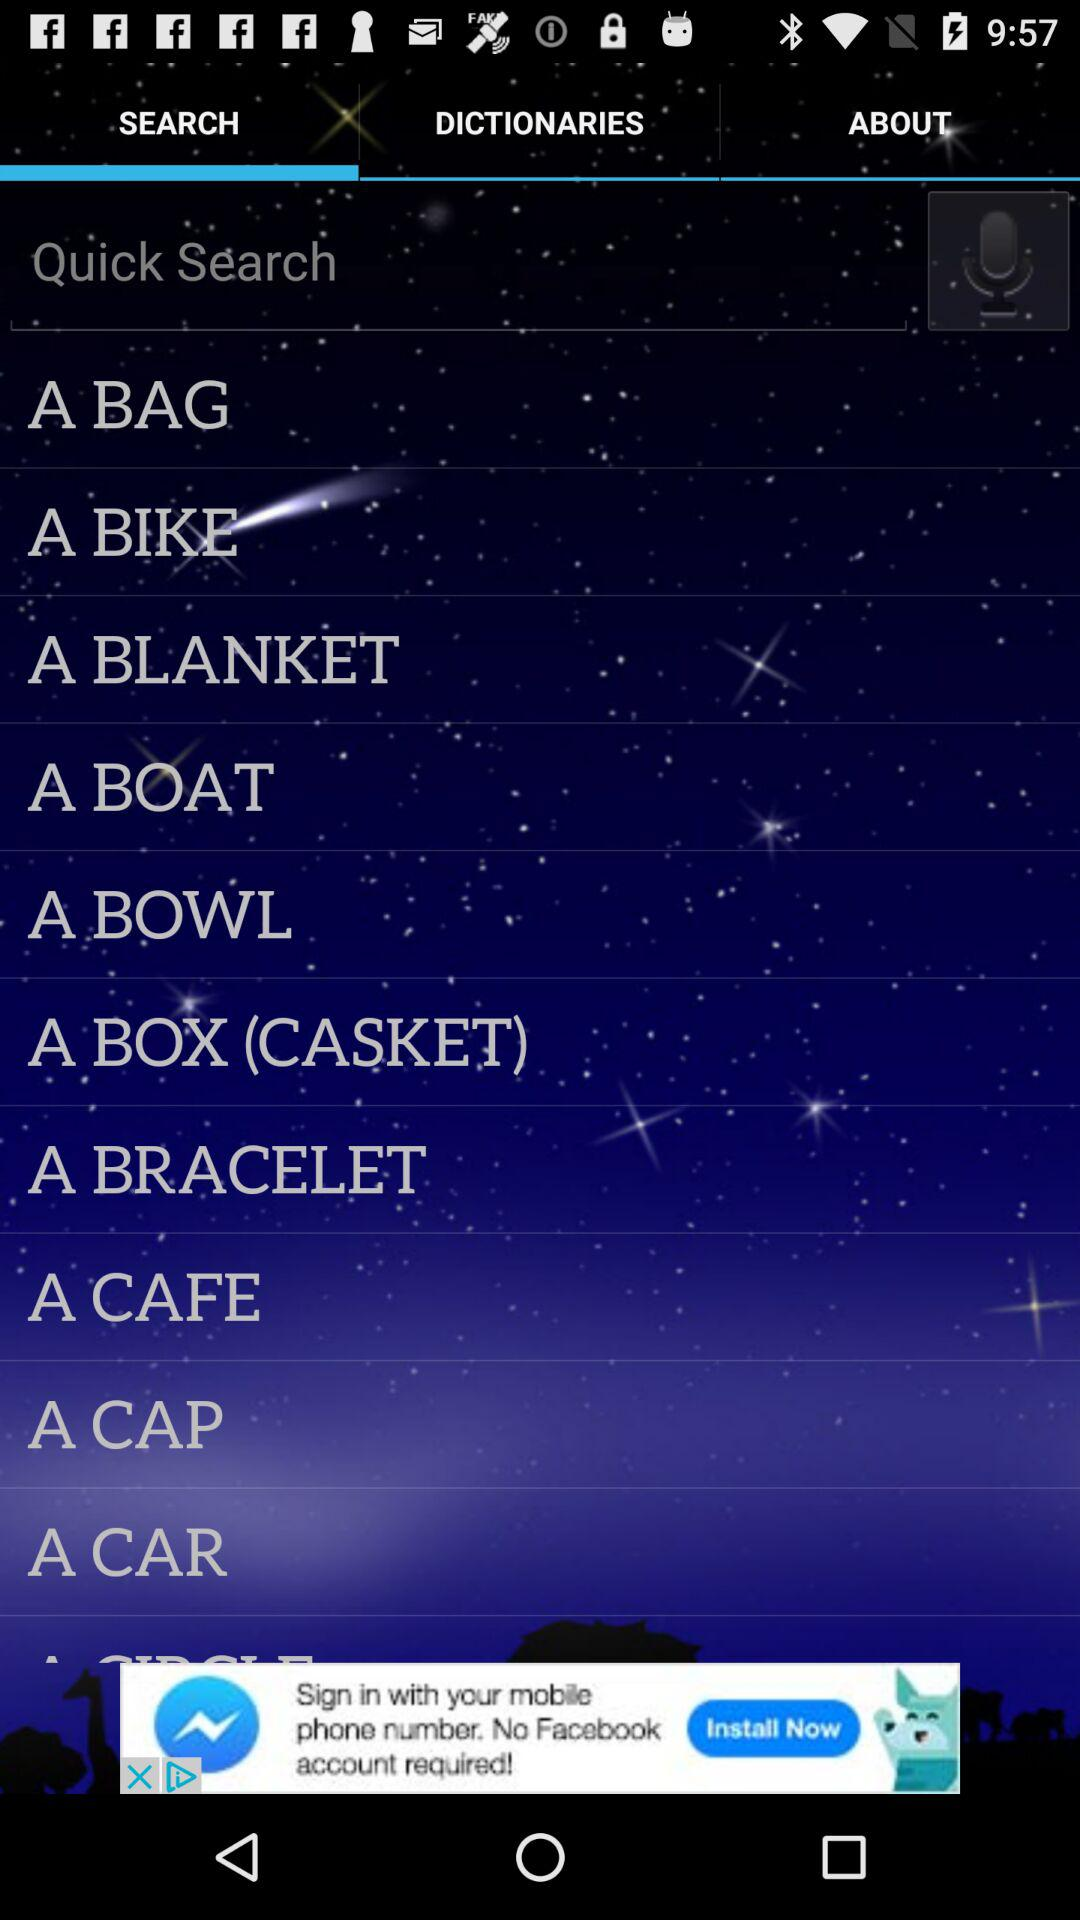Which tab is selected? The selected tab is "SEARCH". 